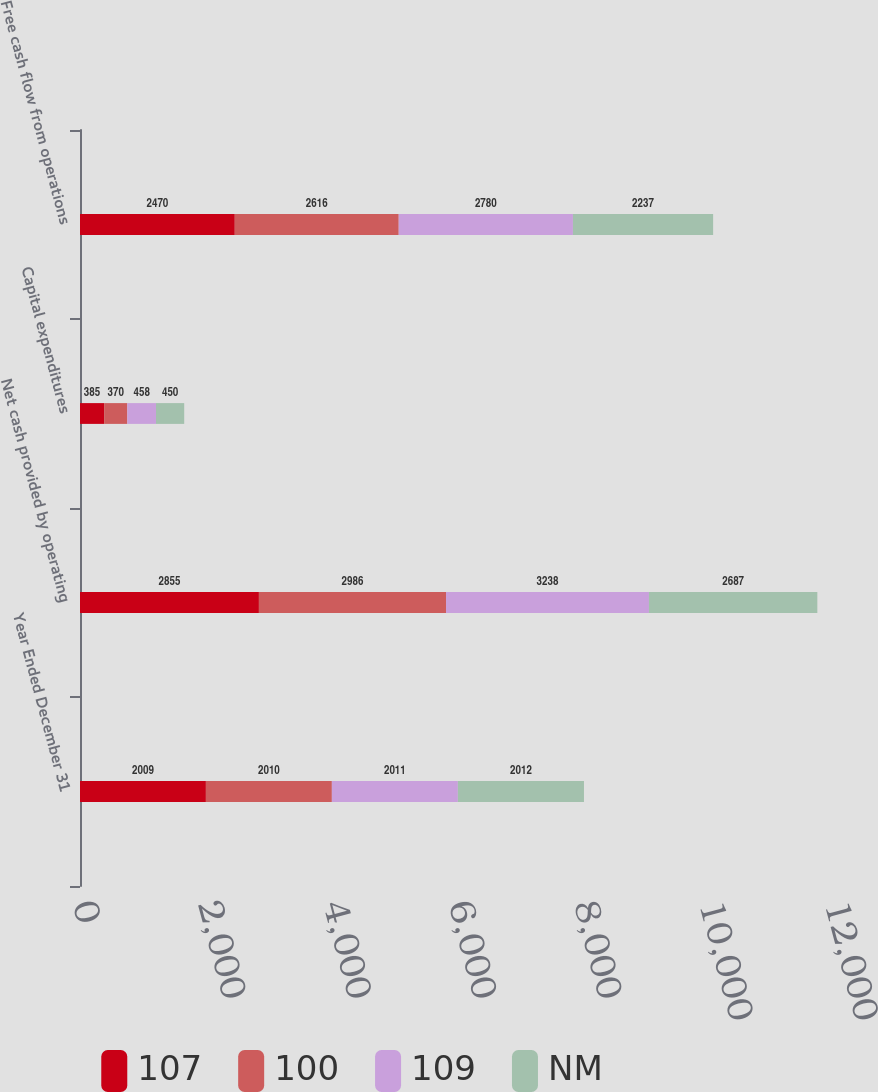<chart> <loc_0><loc_0><loc_500><loc_500><stacked_bar_chart><ecel><fcel>Year Ended December 31<fcel>Net cash provided by operating<fcel>Capital expenditures<fcel>Free cash flow from operations<nl><fcel>107<fcel>2009<fcel>2855<fcel>385<fcel>2470<nl><fcel>100<fcel>2010<fcel>2986<fcel>370<fcel>2616<nl><fcel>109<fcel>2011<fcel>3238<fcel>458<fcel>2780<nl><fcel>NM<fcel>2012<fcel>2687<fcel>450<fcel>2237<nl></chart> 